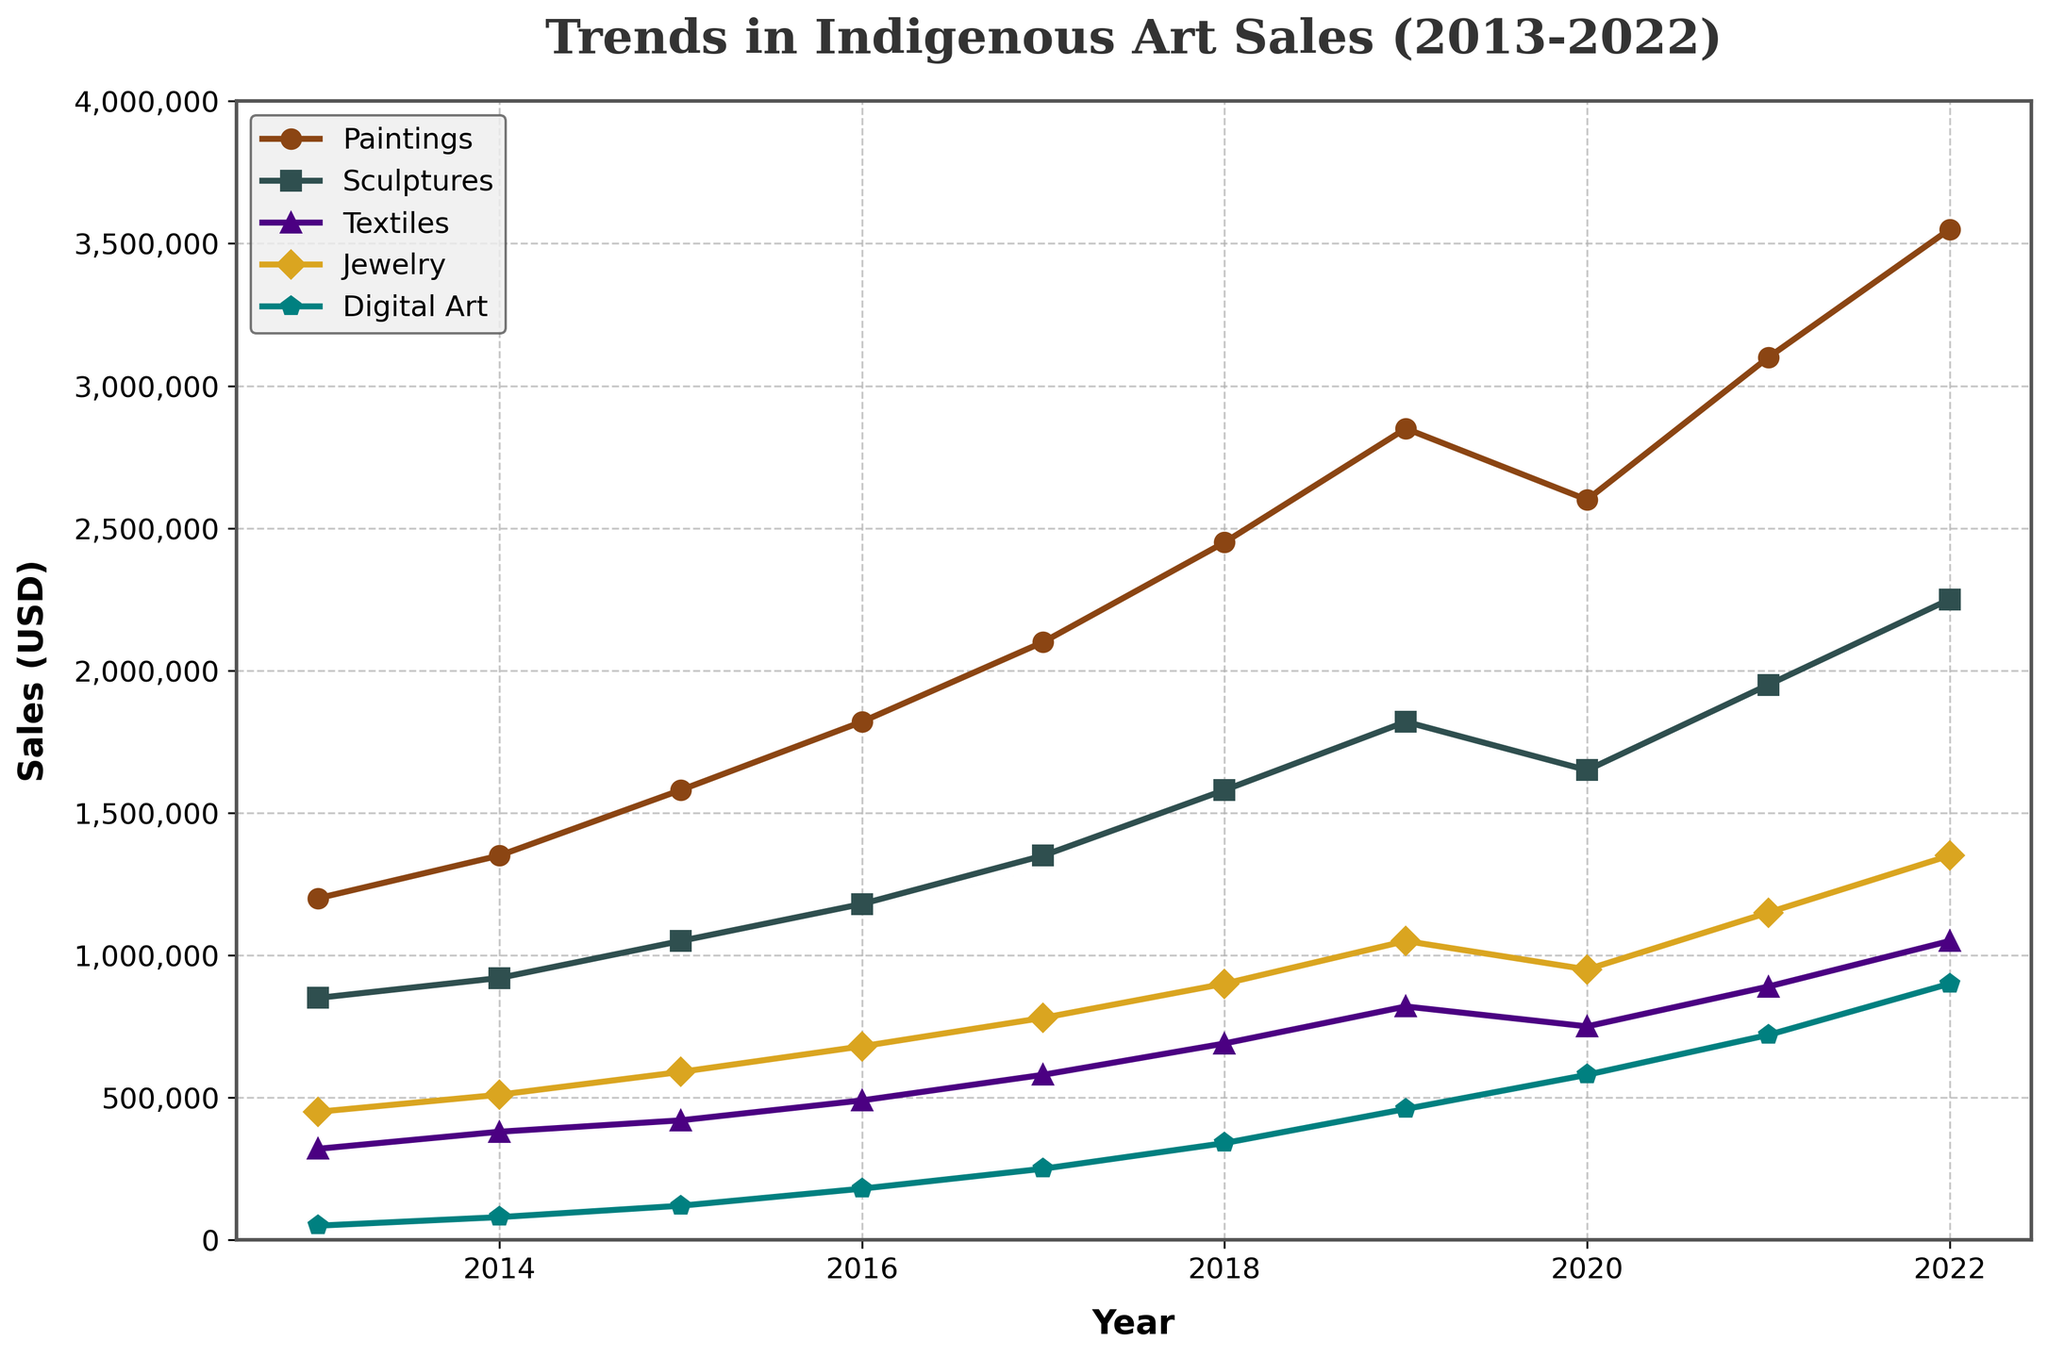What is the overall trend in sales for Paintings over the past decade? Sales for Paintings increase steadily, starting from $1,200,000 in 2013 and reaching $3,550,000 in 2022. This trend shows significant growth in the sales of Paintings over the period.
Answer: The trend for Paintings is increasing What is the average sales value for Jewelry over the decade? Sum the sales values for Jewelry from 2013 to 2022 and divide by the number of years.
Total = $450,000 + $510,000 + $590,000 + $680,000 + $780,000 + $900,000 + $1,050,000 + $950,000 + $1,150,000 + $1,350,000 = $8,410,000
Average = $8,410,000 / 10 = $841,000
Answer: $841,000 How do the sales trends of Digital Art and Sculptures compare? Compare the trends visually: both show consistent growth over the decade. However, Sculptures have consistently higher sales values. In 2022, Digital Art reached $900,000, while Sculptures reached $2,250,000.
Answer: Digital Art shows growth similar to Sculptures but at consistently lower sales values Which year saw the maximum sales for Digital Art? By observing the plotted line for Digital Art, the highest point is in 2022 with sales of $900,000.
Answer: 2022 Which medium had the least sales in 2013, and which one had the least sales in 2022? From the chart:
- In 2013, Digital Art had the least sales at $50,000.
- In 2022, Textiles had the least sales at $1,050,000.
Answer: Digital Art in 2013, Textiles in 2022 